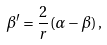Convert formula to latex. <formula><loc_0><loc_0><loc_500><loc_500>\beta ^ { \prime } = \frac { 2 } { r } ( \alpha - \beta ) \, ,</formula> 